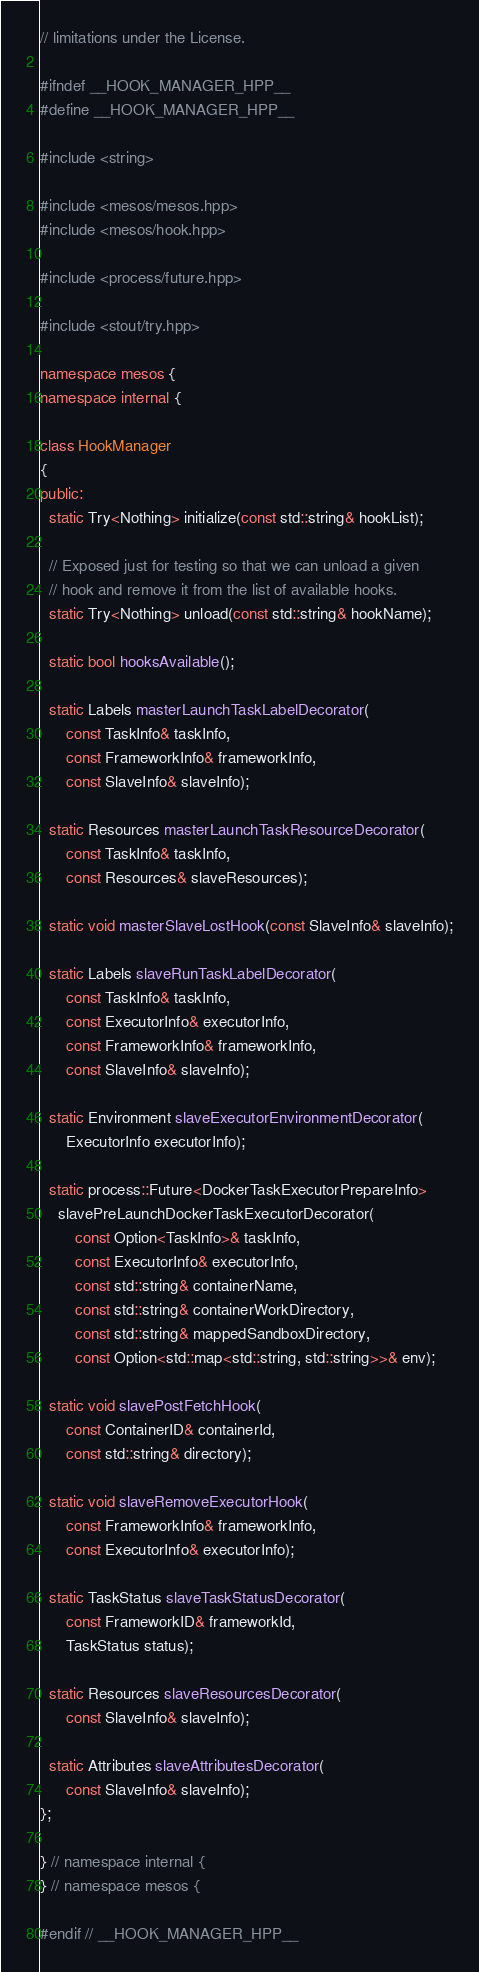<code> <loc_0><loc_0><loc_500><loc_500><_C++_>// limitations under the License.

#ifndef __HOOK_MANAGER_HPP__
#define __HOOK_MANAGER_HPP__

#include <string>

#include <mesos/mesos.hpp>
#include <mesos/hook.hpp>

#include <process/future.hpp>

#include <stout/try.hpp>

namespace mesos {
namespace internal {

class HookManager
{
public:
  static Try<Nothing> initialize(const std::string& hookList);

  // Exposed just for testing so that we can unload a given
  // hook and remove it from the list of available hooks.
  static Try<Nothing> unload(const std::string& hookName);

  static bool hooksAvailable();

  static Labels masterLaunchTaskLabelDecorator(
      const TaskInfo& taskInfo,
      const FrameworkInfo& frameworkInfo,
      const SlaveInfo& slaveInfo);

  static Resources masterLaunchTaskResourceDecorator(
      const TaskInfo& taskInfo,
      const Resources& slaveResources);

  static void masterSlaveLostHook(const SlaveInfo& slaveInfo);

  static Labels slaveRunTaskLabelDecorator(
      const TaskInfo& taskInfo,
      const ExecutorInfo& executorInfo,
      const FrameworkInfo& frameworkInfo,
      const SlaveInfo& slaveInfo);

  static Environment slaveExecutorEnvironmentDecorator(
      ExecutorInfo executorInfo);

  static process::Future<DockerTaskExecutorPrepareInfo>
    slavePreLaunchDockerTaskExecutorDecorator(
        const Option<TaskInfo>& taskInfo,
        const ExecutorInfo& executorInfo,
        const std::string& containerName,
        const std::string& containerWorkDirectory,
        const std::string& mappedSandboxDirectory,
        const Option<std::map<std::string, std::string>>& env);

  static void slavePostFetchHook(
      const ContainerID& containerId,
      const std::string& directory);

  static void slaveRemoveExecutorHook(
      const FrameworkInfo& frameworkInfo,
      const ExecutorInfo& executorInfo);

  static TaskStatus slaveTaskStatusDecorator(
      const FrameworkID& frameworkId,
      TaskStatus status);

  static Resources slaveResourcesDecorator(
      const SlaveInfo& slaveInfo);

  static Attributes slaveAttributesDecorator(
      const SlaveInfo& slaveInfo);
};

} // namespace internal {
} // namespace mesos {

#endif // __HOOK_MANAGER_HPP__
</code> 